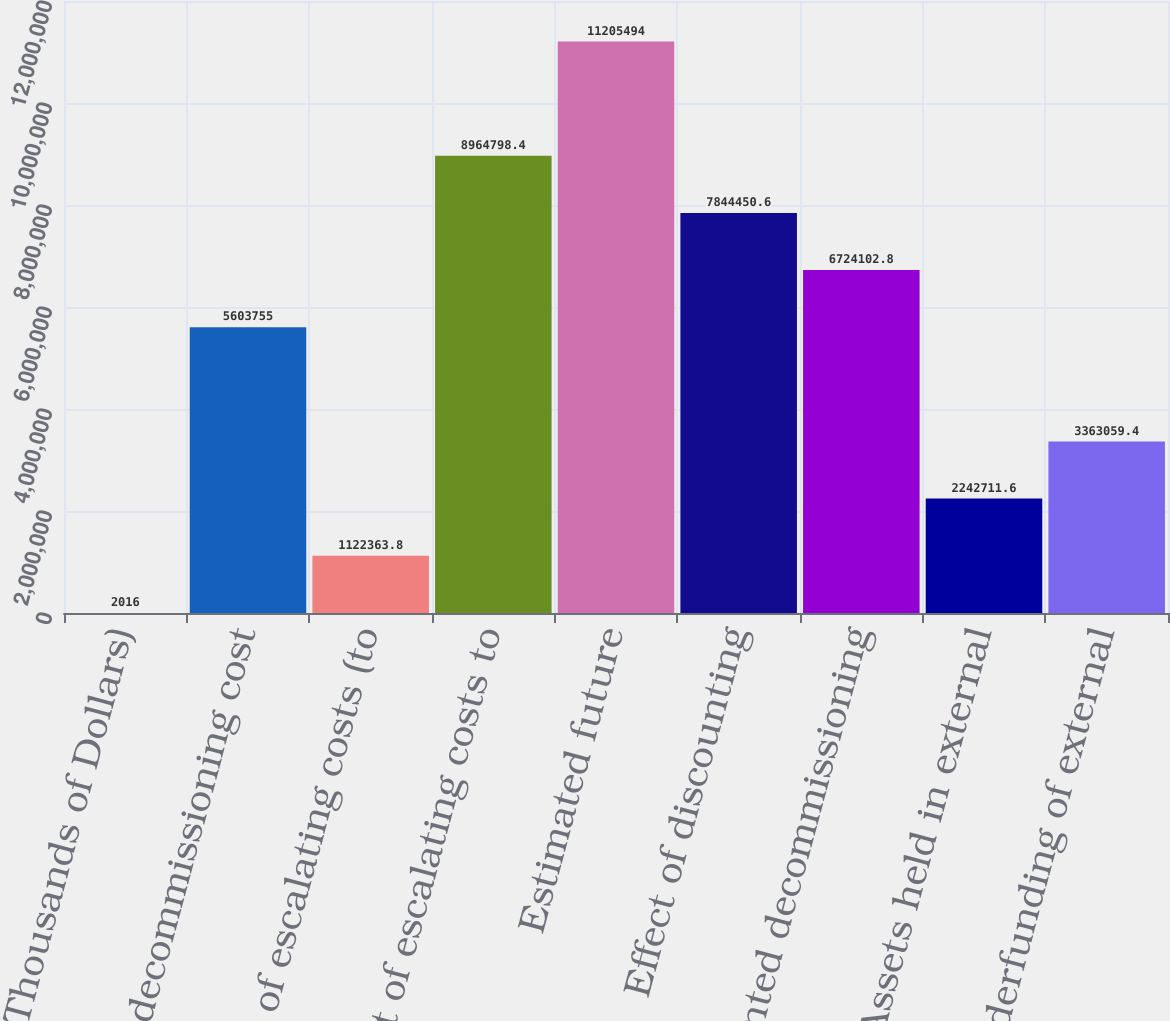Convert chart. <chart><loc_0><loc_0><loc_500><loc_500><bar_chart><fcel>(Thousands of Dollars)<fcel>Estimated decommissioning cost<fcel>Effect of escalating costs (to<fcel>Effect of escalating costs to<fcel>Estimated future<fcel>Effect of discounting<fcel>Discounted decommissioning<fcel>Assets held in external<fcel>Underfunding of external<nl><fcel>2016<fcel>5.60376e+06<fcel>1.12236e+06<fcel>8.9648e+06<fcel>1.12055e+07<fcel>7.84445e+06<fcel>6.7241e+06<fcel>2.24271e+06<fcel>3.36306e+06<nl></chart> 